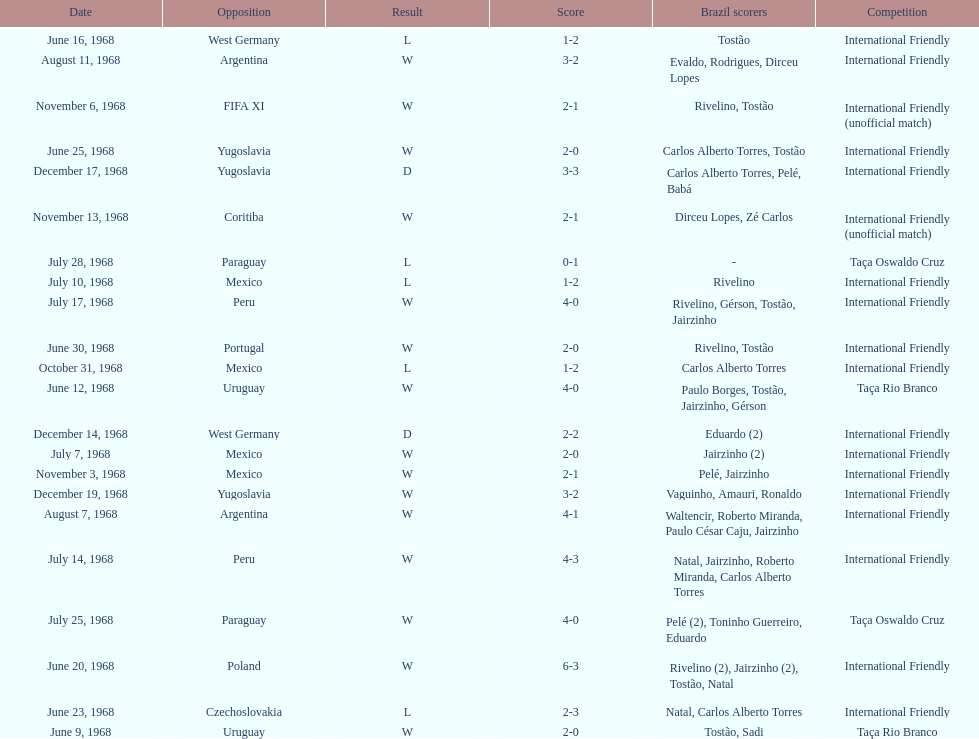What is the top score ever scored by the brazil national team? 6. 